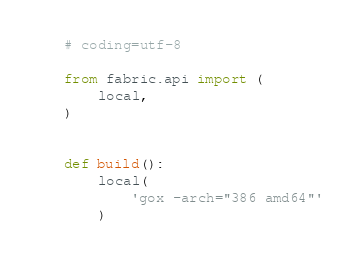Convert code to text. <code><loc_0><loc_0><loc_500><loc_500><_Python_># coding=utf-8

from fabric.api import (
    local,
)


def build():
    local(
        'gox -arch="386 amd64"'
    )
</code> 